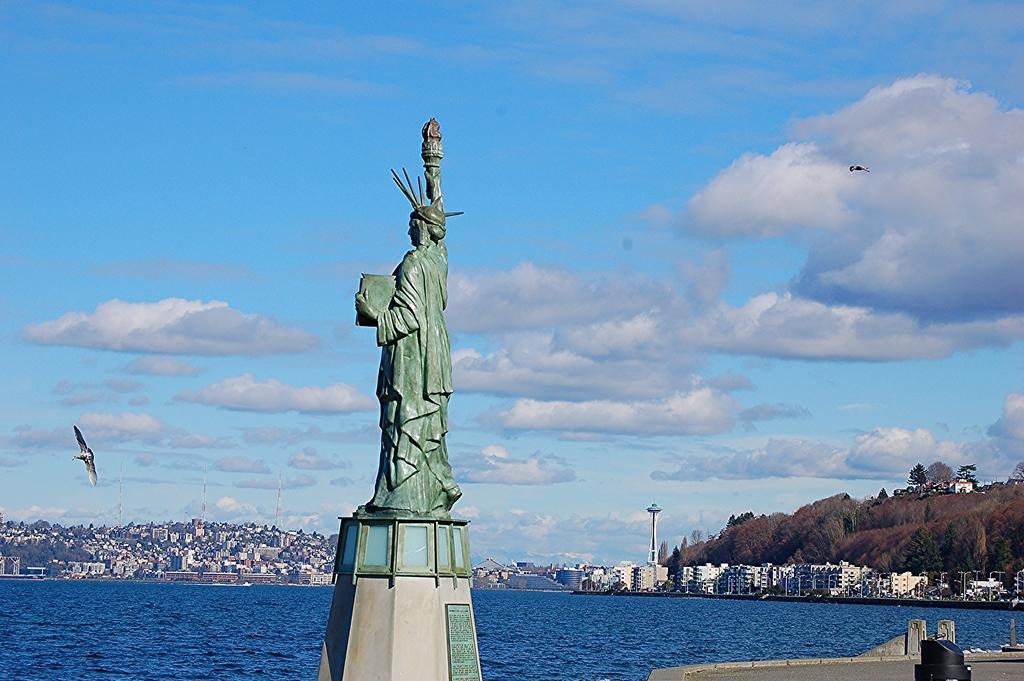In one or two sentences, can you explain what this image depicts? In this image in the front there is a statue. In the center there is water in the background there are buildings trees and the sky is cloudy and there are birds flying in the sky. 